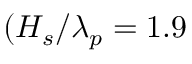Convert formula to latex. <formula><loc_0><loc_0><loc_500><loc_500>( H _ { s } / \lambda _ { p } = 1 . 9 \</formula> 